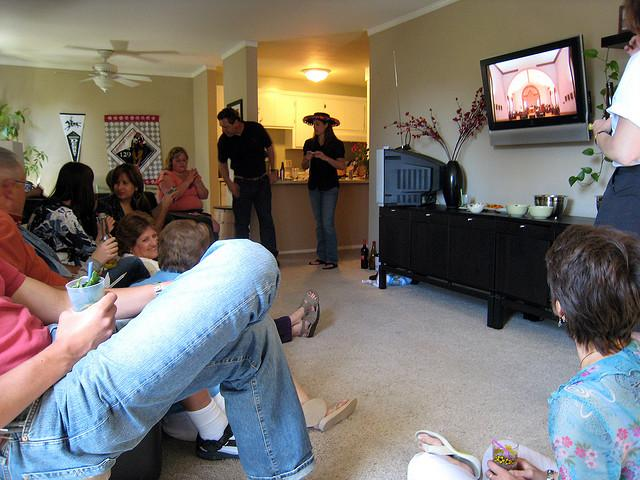What are the people looking at in the room?

Choices:
A) painting
B) window
C) television
D) artwork television 